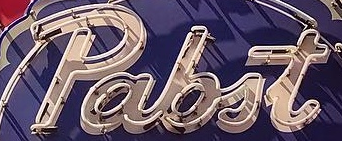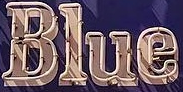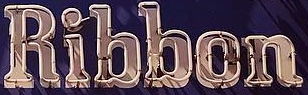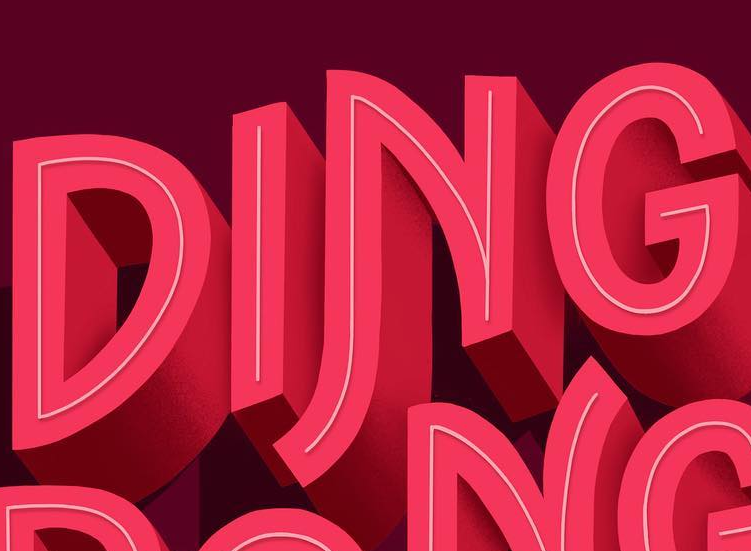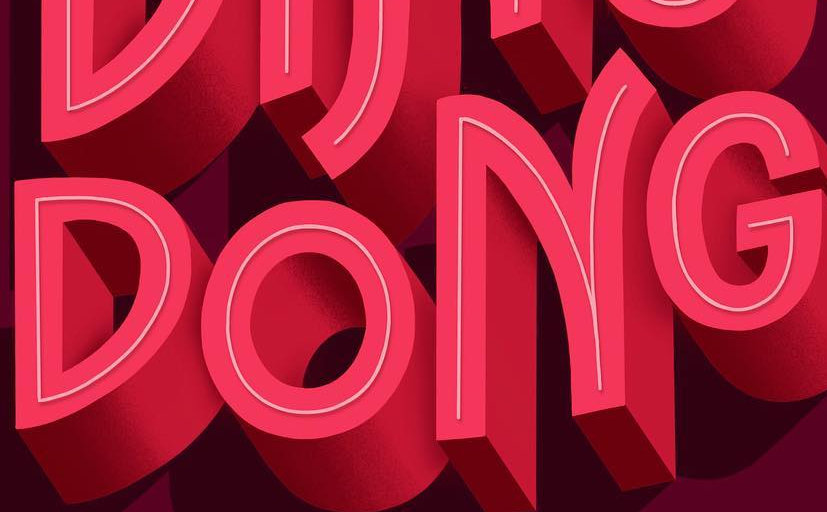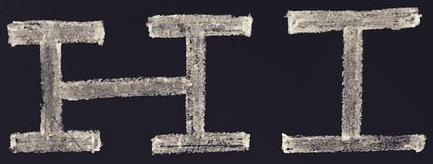What text is displayed in these images sequentially, separated by a semicolon? pabit; Blue; Ribbon; DING; DONG; HI 